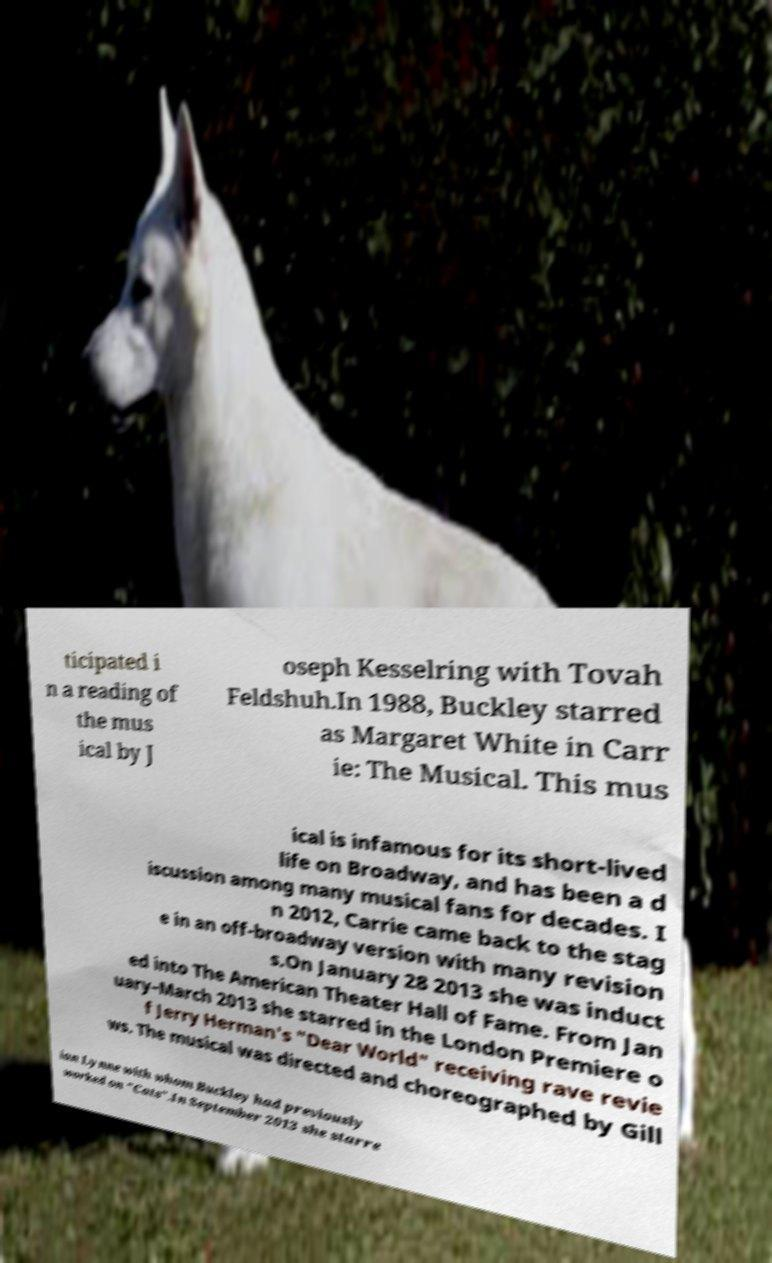Could you assist in decoding the text presented in this image and type it out clearly? ticipated i n a reading of the mus ical by J oseph Kesselring with Tovah Feldshuh.In 1988, Buckley starred as Margaret White in Carr ie: The Musical. This mus ical is infamous for its short-lived life on Broadway, and has been a d iscussion among many musical fans for decades. I n 2012, Carrie came back to the stag e in an off-broadway version with many revision s.On January 28 2013 she was induct ed into The American Theater Hall of Fame. From Jan uary–March 2013 she starred in the London Premiere o f Jerry Herman's "Dear World" receiving rave revie ws. The musical was directed and choreographed by Gill ian Lynne with whom Buckley had previously worked on "Cats".In September 2013 she starre 